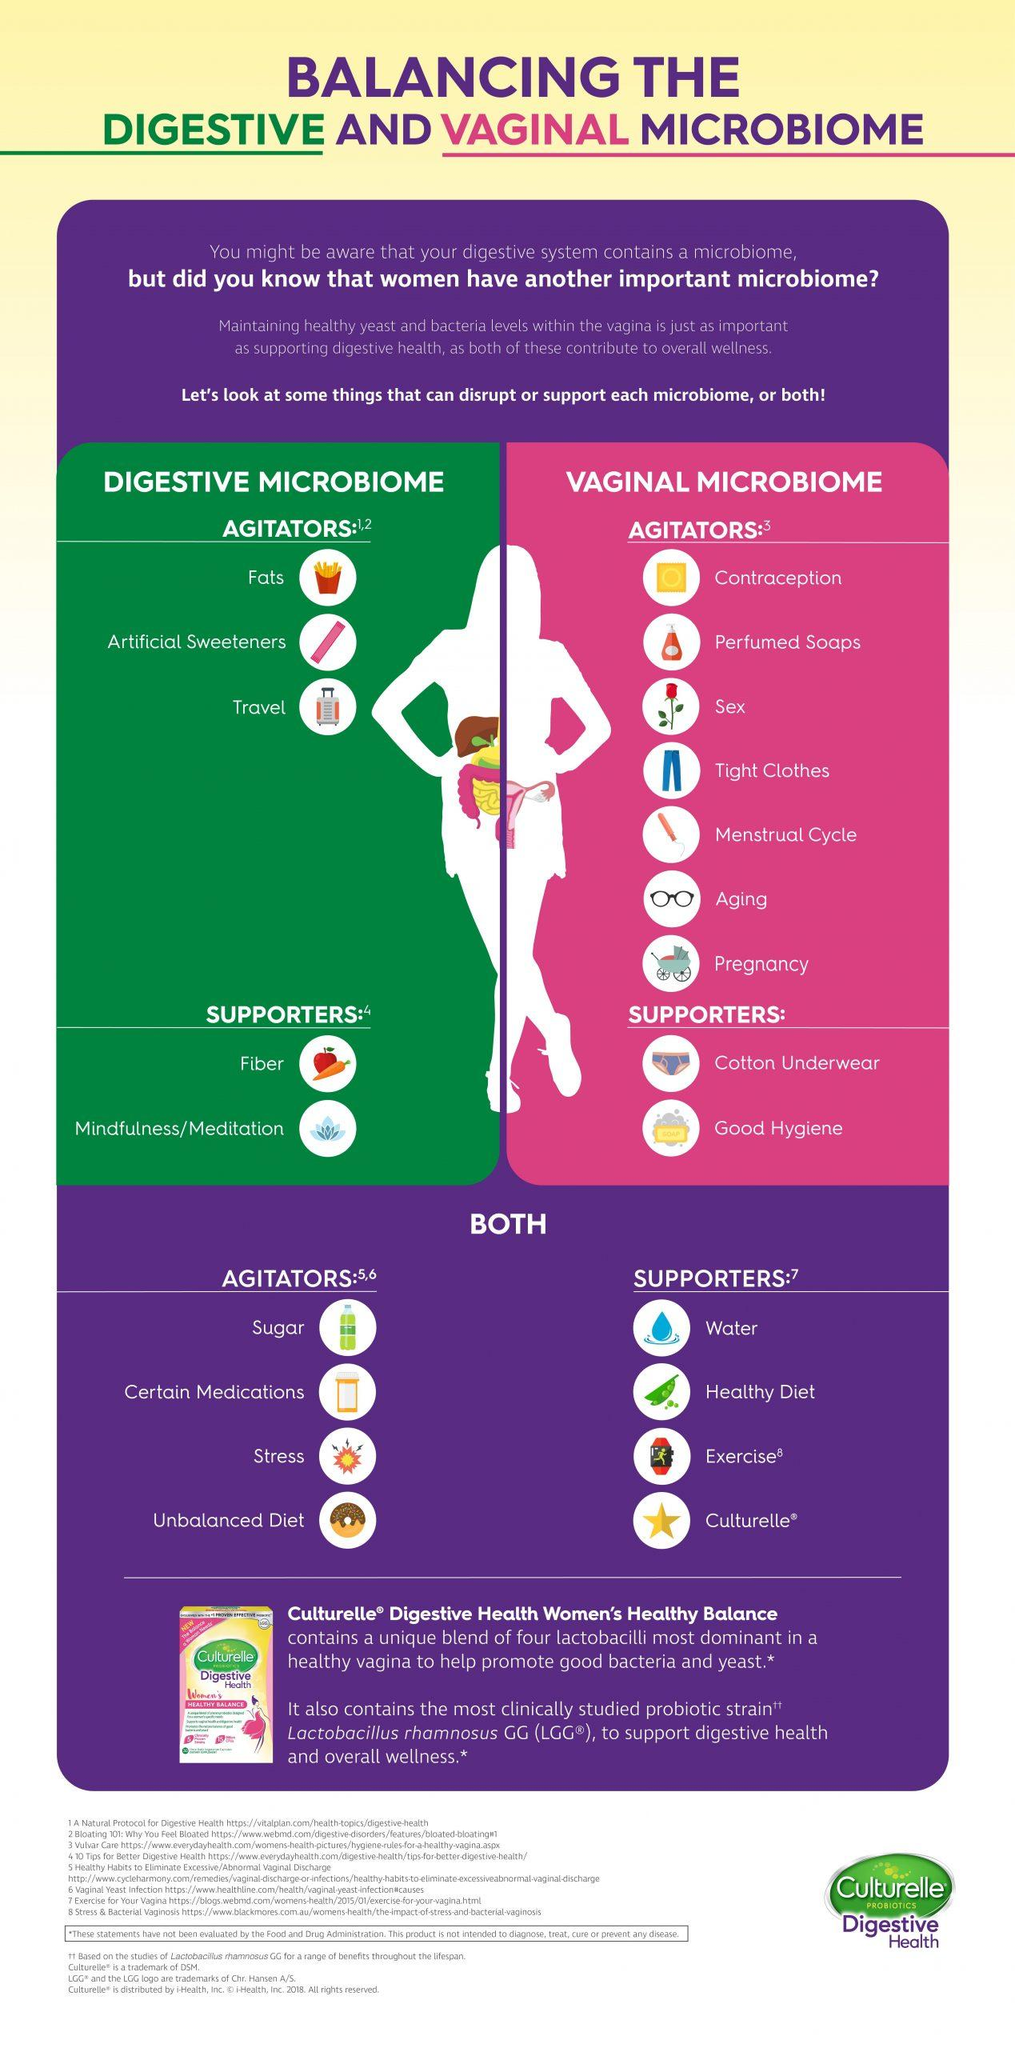Mention a couple of crucial points in this snapshot. The agitators of the digestive microbiome are fats, artificial sweeteners, and travel. Culturelle is a commercial product that supports the digestive and vaginal microbiomes. Supporters of the digestive microbiome include fiber and meditation. 